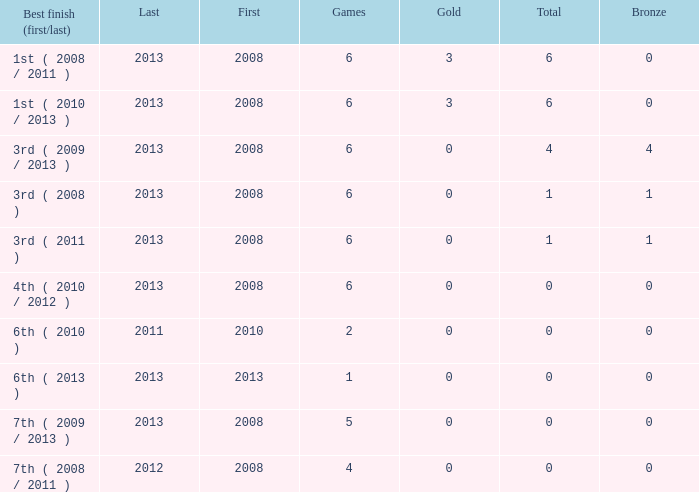What is the fewest number of medals associated with under 6 games and over 0 golds? None. Could you parse the entire table? {'header': ['Best finish (first/last)', 'Last', 'First', 'Games', 'Gold', 'Total', 'Bronze'], 'rows': [['1st ( 2008 / 2011 )', '2013', '2008', '6', '3', '6', '0'], ['1st ( 2010 / 2013 )', '2013', '2008', '6', '3', '6', '0'], ['3rd ( 2009 / 2013 )', '2013', '2008', '6', '0', '4', '4'], ['3rd ( 2008 )', '2013', '2008', '6', '0', '1', '1'], ['3rd ( 2011 )', '2013', '2008', '6', '0', '1', '1'], ['4th ( 2010 / 2012 )', '2013', '2008', '6', '0', '0', '0'], ['6th ( 2010 )', '2011', '2010', '2', '0', '0', '0'], ['6th ( 2013 )', '2013', '2013', '1', '0', '0', '0'], ['7th ( 2009 / 2013 )', '2013', '2008', '5', '0', '0', '0'], ['7th ( 2008 / 2011 )', '2012', '2008', '4', '0', '0', '0']]} 